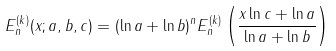<formula> <loc_0><loc_0><loc_500><loc_500>{ E } ^ { ( k ) } _ { n } ( x ; a , b , c ) = ( \ln a + \ln b ) ^ { n } { E } ^ { ( k ) } _ { n } \left ( \frac { x \ln c + \ln a } { \ln a + \ln b } \right )</formula> 